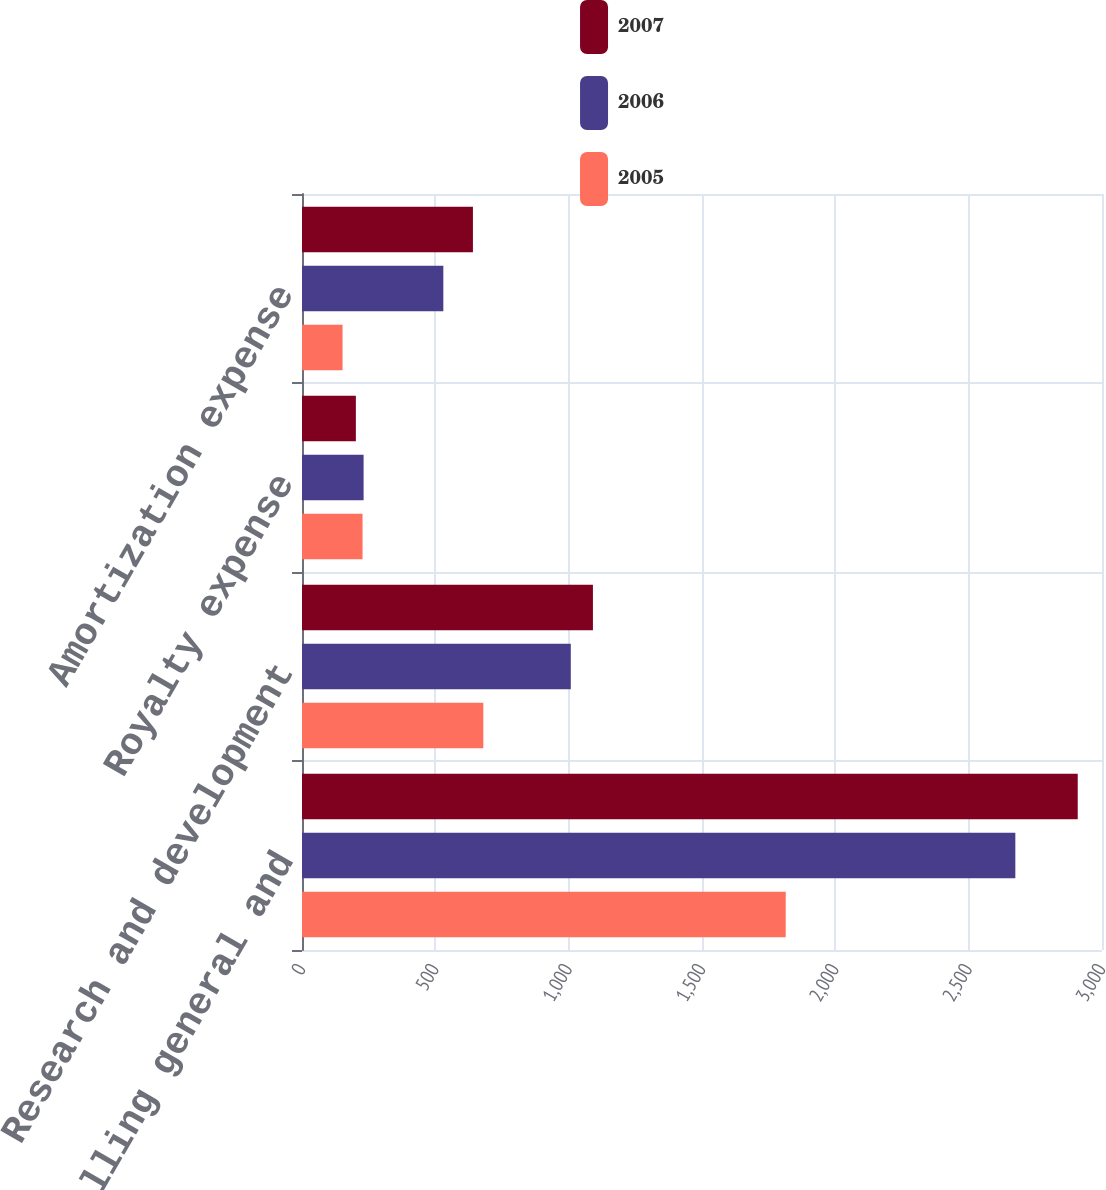Convert chart to OTSL. <chart><loc_0><loc_0><loc_500><loc_500><stacked_bar_chart><ecel><fcel>Selling general and<fcel>Research and development<fcel>Royalty expense<fcel>Amortization expense<nl><fcel>2007<fcel>2909<fcel>1091<fcel>202<fcel>641<nl><fcel>2006<fcel>2675<fcel>1008<fcel>231<fcel>530<nl><fcel>2005<fcel>1814<fcel>680<fcel>227<fcel>152<nl></chart> 